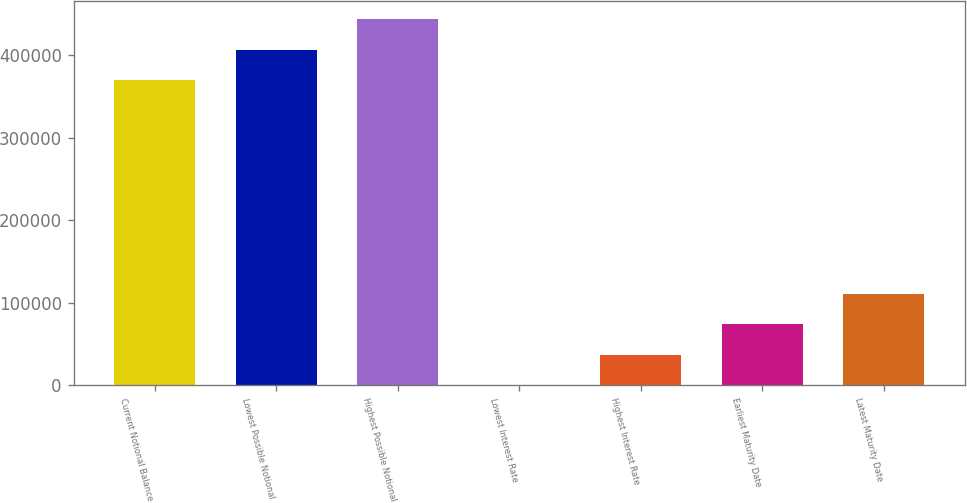Convert chart to OTSL. <chart><loc_0><loc_0><loc_500><loc_500><bar_chart><fcel>Current Notional Balance<fcel>Lowest Possible Notional<fcel>Highest Possible Notional<fcel>Lowest Interest Rate<fcel>Highest Interest Rate<fcel>Earliest Maturity Date<fcel>Latest Maturity Date<nl><fcel>370000<fcel>407000<fcel>443999<fcel>3.25<fcel>37002.9<fcel>74002.6<fcel>111002<nl></chart> 